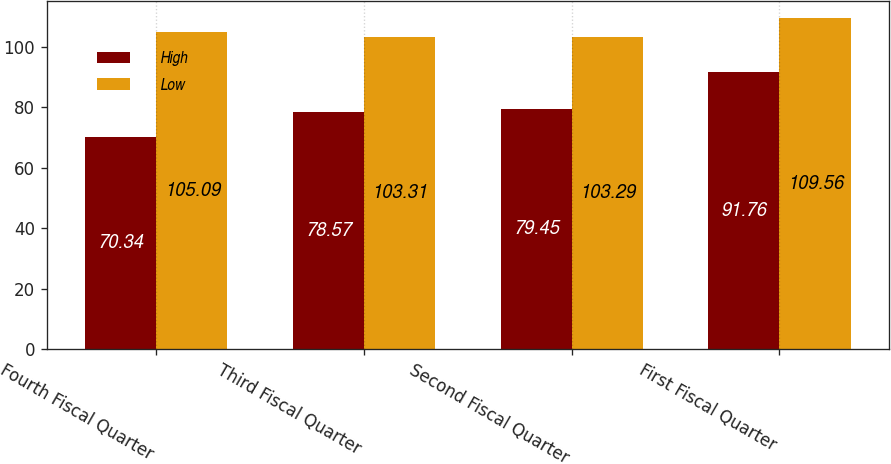Convert chart to OTSL. <chart><loc_0><loc_0><loc_500><loc_500><stacked_bar_chart><ecel><fcel>Fourth Fiscal Quarter<fcel>Third Fiscal Quarter<fcel>Second Fiscal Quarter<fcel>First Fiscal Quarter<nl><fcel>High<fcel>70.34<fcel>78.57<fcel>79.45<fcel>91.76<nl><fcel>Low<fcel>105.09<fcel>103.31<fcel>103.29<fcel>109.56<nl></chart> 